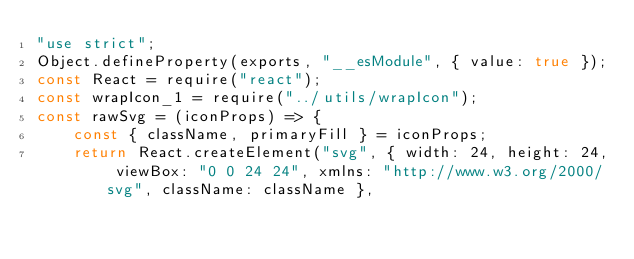Convert code to text. <code><loc_0><loc_0><loc_500><loc_500><_JavaScript_>"use strict";
Object.defineProperty(exports, "__esModule", { value: true });
const React = require("react");
const wrapIcon_1 = require("../utils/wrapIcon");
const rawSvg = (iconProps) => {
    const { className, primaryFill } = iconProps;
    return React.createElement("svg", { width: 24, height: 24, viewBox: "0 0 24 24", xmlns: "http://www.w3.org/2000/svg", className: className },</code> 